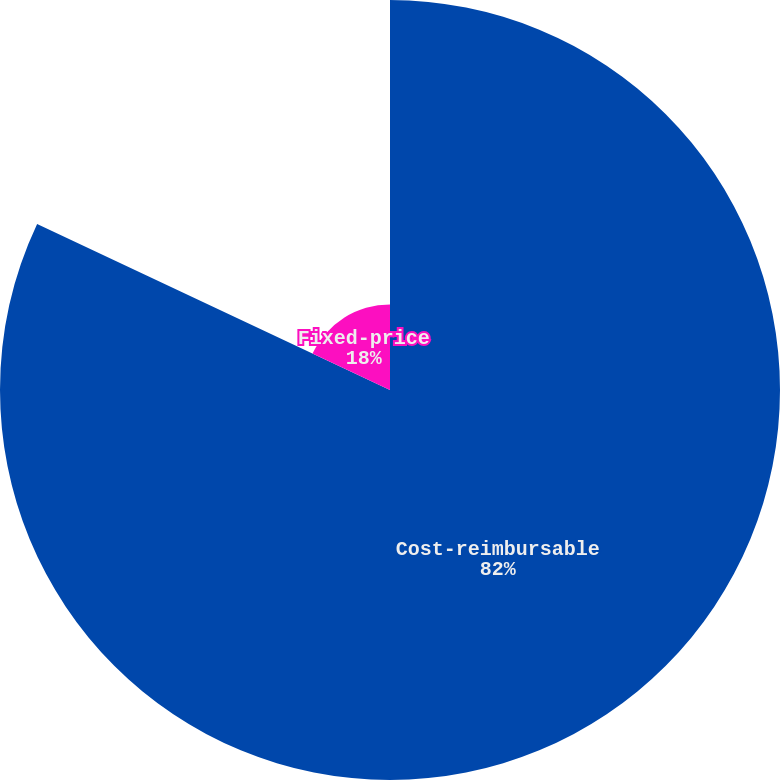Convert chart to OTSL. <chart><loc_0><loc_0><loc_500><loc_500><pie_chart><fcel>Cost-reimbursable<fcel>Fixed-price<nl><fcel>82.0%<fcel>18.0%<nl></chart> 